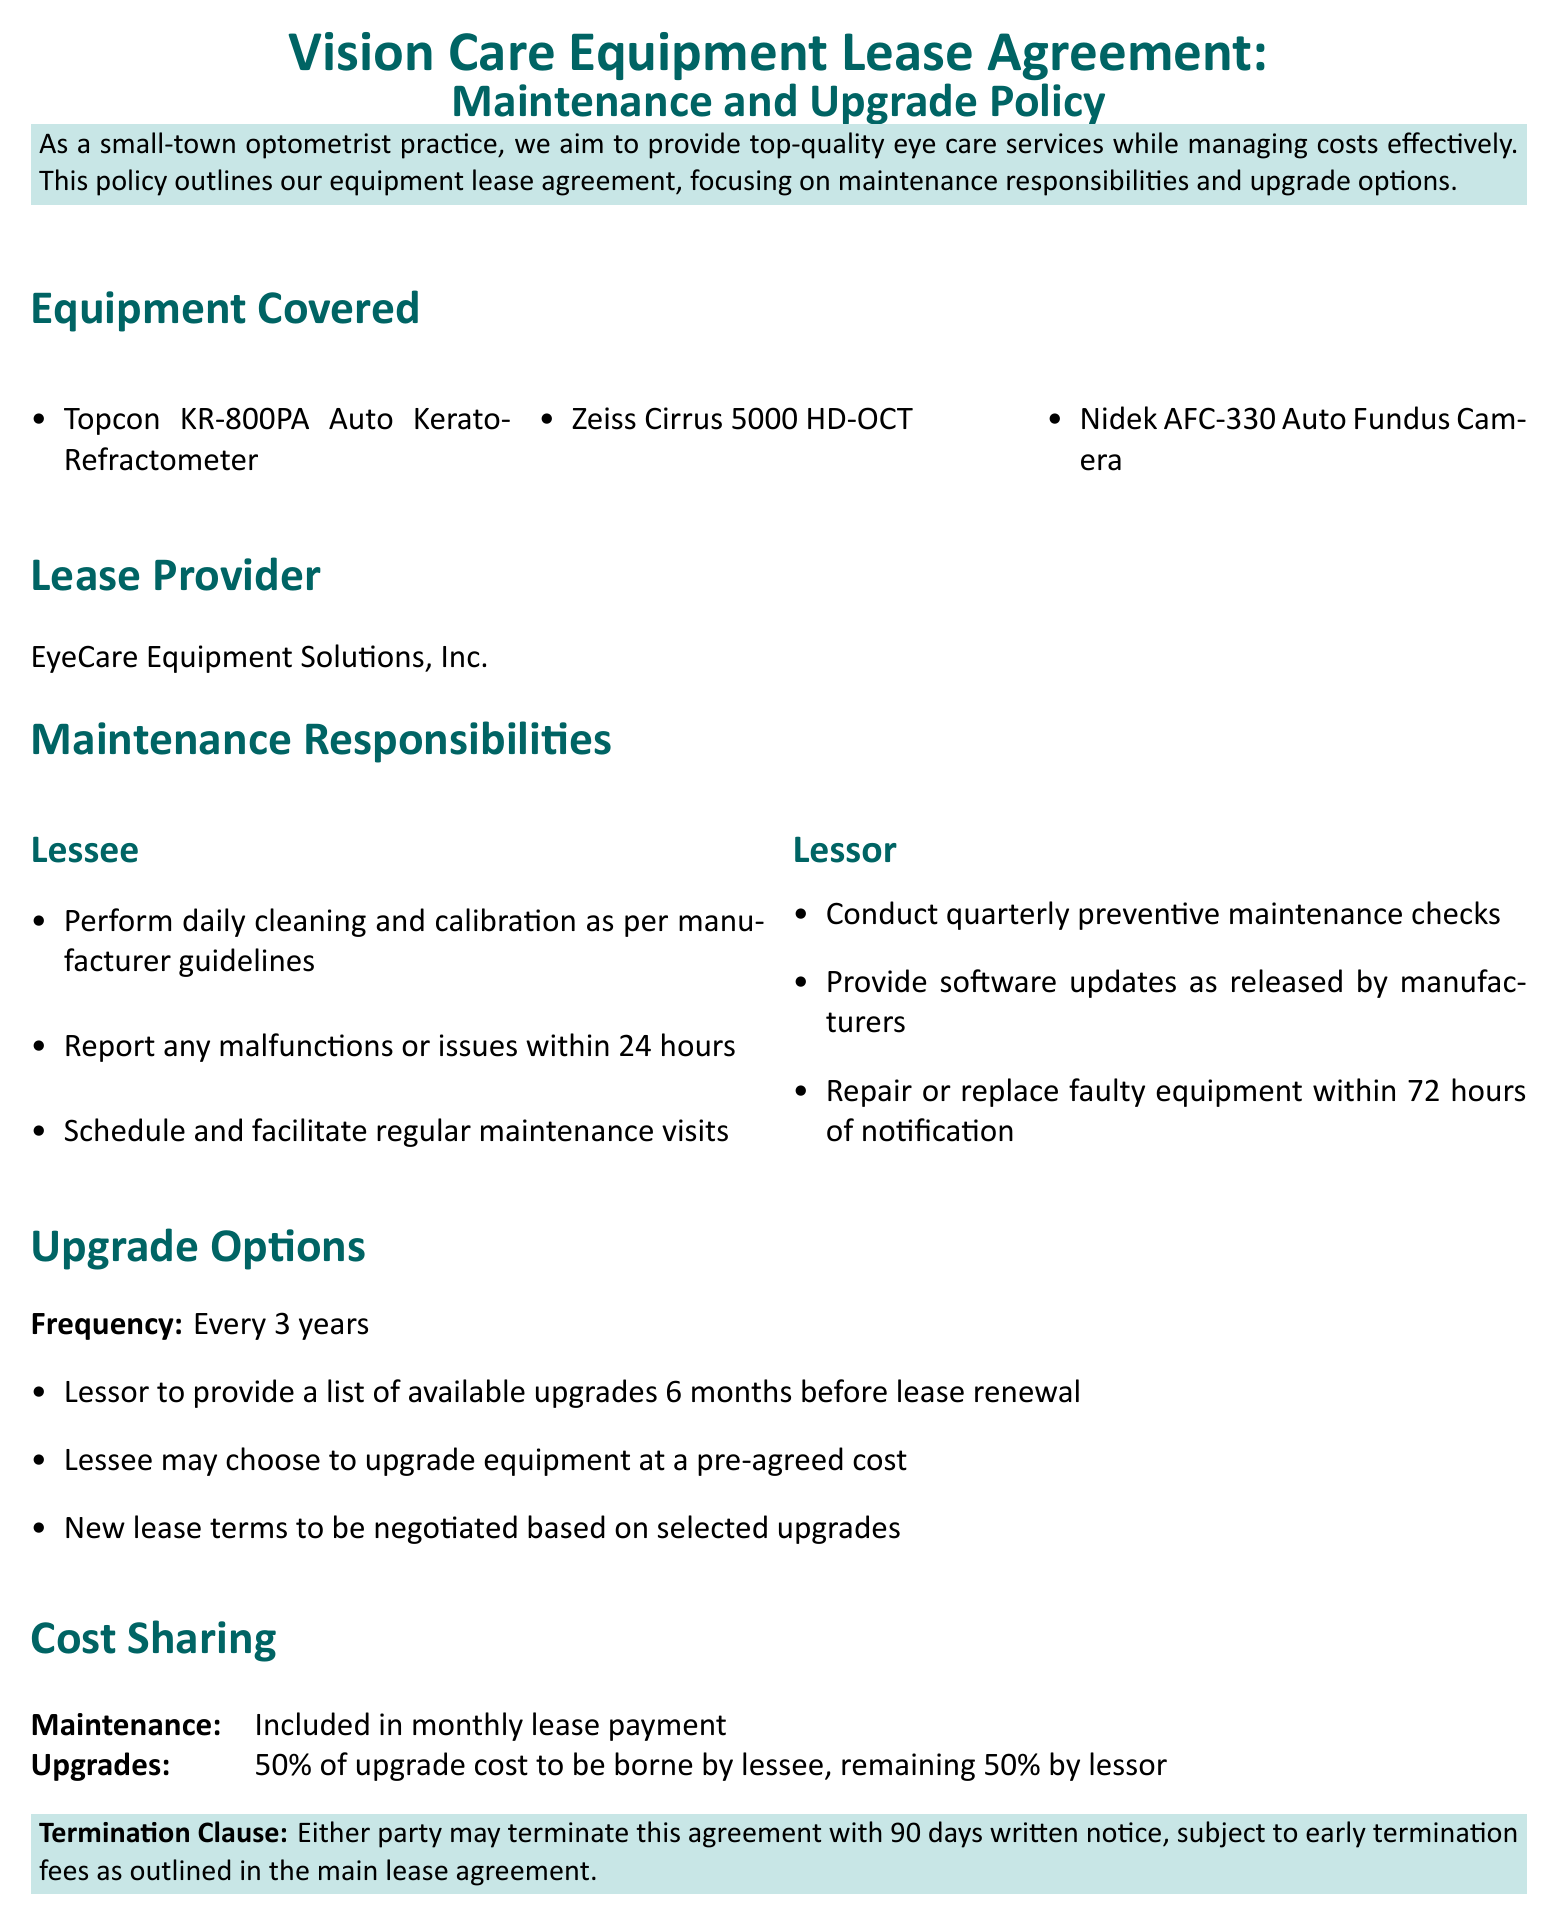What is the frequency of upgrades? The upgrades are specified to occur every three years as per the document.
Answer: Every 3 years Who is the lease provider? The lease provider is specifically named in the document.
Answer: EyeCare Equipment Solutions, Inc What are the three pieces of equipment covered? The document lists three specific equipment items under "Equipment Covered".
Answer: Topcon KR-800PA Auto Kerato-Refractometer, Zeiss Cirrus 5000 HD-OCT, Nidek AFC-330 Auto Fundus Camera What is the lessee's responsibility regarding malfunctions? The document outlines the lessee's obligation to report malfunctions; the required timeframe is specified.
Answer: Within 24 hours What percentage of upgrade cost is borne by the lessee? The sharing responsibility for upgrade costs is outlined in the "Cost Sharing" section of the document.
Answer: 50% What is included in the monthly lease payment? The document specifies what is included, relating to maintenance.
Answer: Maintenance What is the time frame for termination notice? The termination clause provides specific notice requirements that must be adhered to by both parties.
Answer: 90 days What is the lessor required to provide for software? The maintenance responsibilities section outlines a specific obligation regarding updates related to software.
Answer: Software updates How quickly must faulty equipment be repaired? The document specifically mentions the timeline for equipment repair upon notification.
Answer: Within 72 hours 